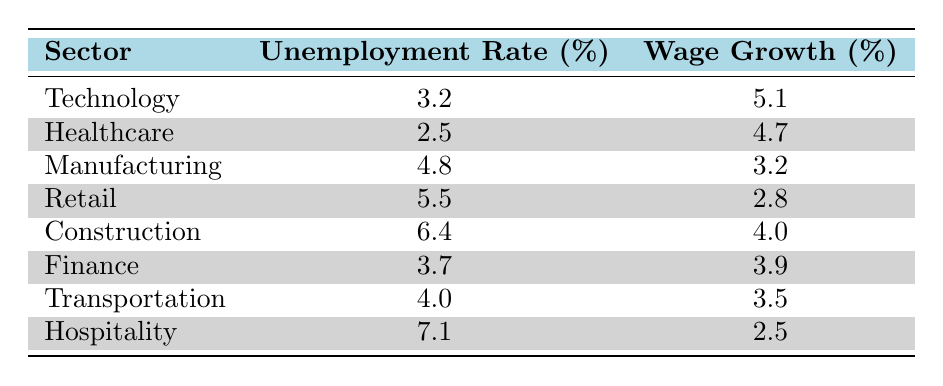What is the unemployment rate in the Healthcare sector? The table lists the unemployment rate for the Healthcare sector as 2.5%.
Answer: 2.5% Which sector has the highest wage growth? By reviewing the wage growth figures, Technology has the highest wage growth at 5.1%.
Answer: 5.1% What is the difference in unemployment rates between the Retail and Construction sectors? The unemployment rate for Retail is 5.5%, and for Construction, it is 6.4%. The difference is 6.4 - 5.5 = 0.9%.
Answer: 0.9% Is it true that the Hospitality sector has a wage growth greater than 3%? The wage growth for Hospitality is 2.5%, which is less than 3%, so the statement is false.
Answer: No What is the average unemployment rate across all sectors? To find the average unemployment rate, we add the rates (3.2 + 2.5 + 4.8 + 5.5 + 6.4 + 3.7 + 4.0 + 7.1) = 37.2%; dividing by 8 sectors gives 37.2/8 = 4.65%.
Answer: 4.65% Which sector shows a wage growth lower than 3%? The table shows that both Retail (2.8%) and Hospitality (2.5%) have wage growth lower than 3%.
Answer: Retail and Hospitality If the unemployment rate increases by 1% in the Technology sector, what will the new rate be? The current unemployment rate in Technology is 3.2%. Adding 1% to this gives 4.2%.
Answer: 4.2% Is the wage growth in the Manufacturing sector higher than that in the Transportation sector? Manufacturing has a wage growth of 3.2%, while Transportation has 3.5%. Since 3.2% is lower than 3.5%, the statement is false.
Answer: No Which sector has the lowest unemployment rate? By checking the unemployment rates listed, Healthcare has the lowest at 2.5%.
Answer: 2.5% 